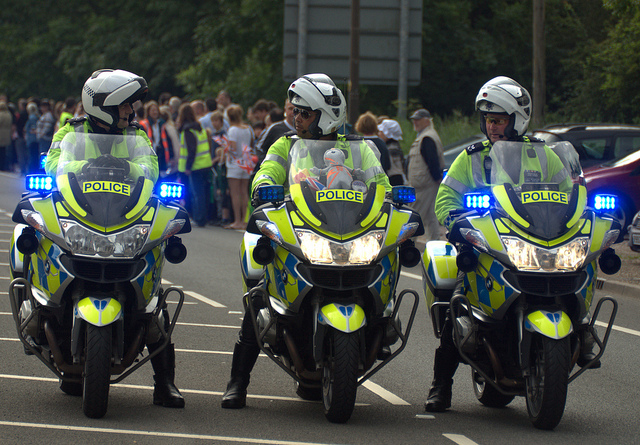Please identify all text content in this image. POLICE POLICE POLICE 